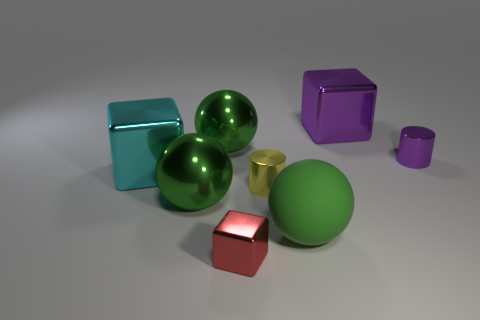Add 2 green objects. How many objects exist? 10 Subtract all balls. How many objects are left? 5 Subtract 0 red cylinders. How many objects are left? 8 Subtract all large green metal things. Subtract all big shiny spheres. How many objects are left? 4 Add 2 large metal blocks. How many large metal blocks are left? 4 Add 8 green metal objects. How many green metal objects exist? 10 